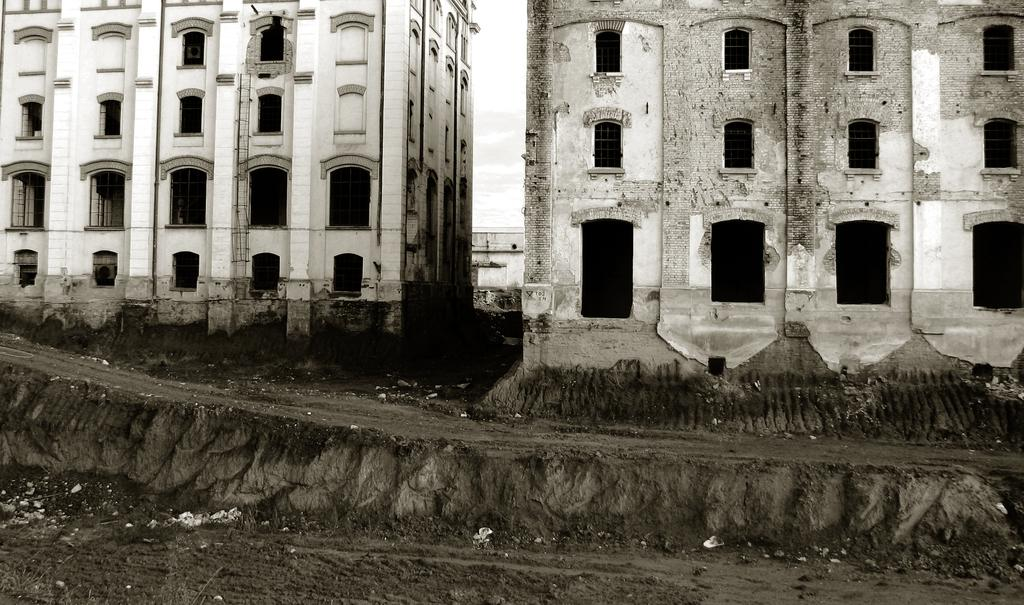What type of structures can be seen in the image? There are buildings in the image. What architectural feature is present on the buildings? Arches are visible on the buildings. Where is the station located in the image? There is no station present in the image. What type of writing instrument is used by the person in the image? There is no person or writing instrument present in the image. 